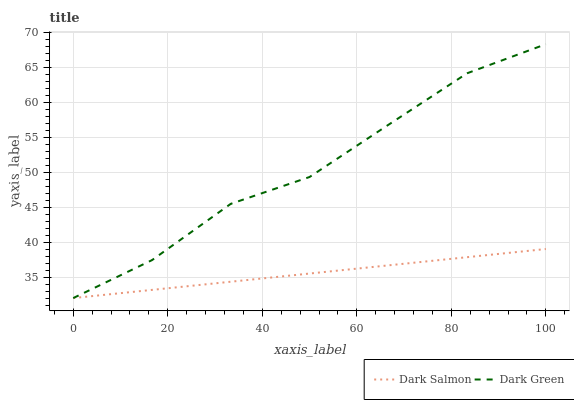Does Dark Salmon have the minimum area under the curve?
Answer yes or no. Yes. Does Dark Green have the maximum area under the curve?
Answer yes or no. Yes. Does Dark Green have the minimum area under the curve?
Answer yes or no. No. Is Dark Salmon the smoothest?
Answer yes or no. Yes. Is Dark Green the roughest?
Answer yes or no. Yes. Is Dark Green the smoothest?
Answer yes or no. No. Does Dark Salmon have the lowest value?
Answer yes or no. Yes. Does Dark Green have the highest value?
Answer yes or no. Yes. Does Dark Salmon intersect Dark Green?
Answer yes or no. Yes. Is Dark Salmon less than Dark Green?
Answer yes or no. No. Is Dark Salmon greater than Dark Green?
Answer yes or no. No. 